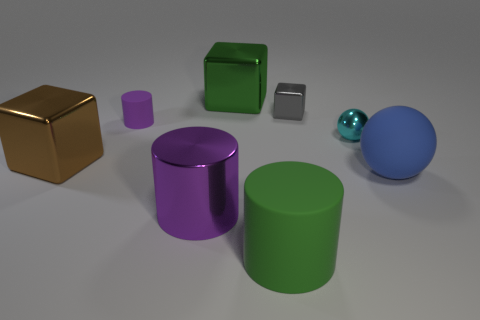Subtract all large shiny blocks. How many blocks are left? 1 Subtract all cyan balls. How many balls are left? 1 Add 1 big cyan metal cylinders. How many objects exist? 9 Subtract all cubes. How many objects are left? 5 Subtract 1 spheres. How many spheres are left? 1 Subtract all red spheres. Subtract all gray cylinders. How many spheres are left? 2 Subtract all green spheres. How many purple cylinders are left? 2 Subtract all big purple metallic things. Subtract all gray metal things. How many objects are left? 6 Add 7 big brown metal things. How many big brown metal things are left? 8 Add 5 small purple cylinders. How many small purple cylinders exist? 6 